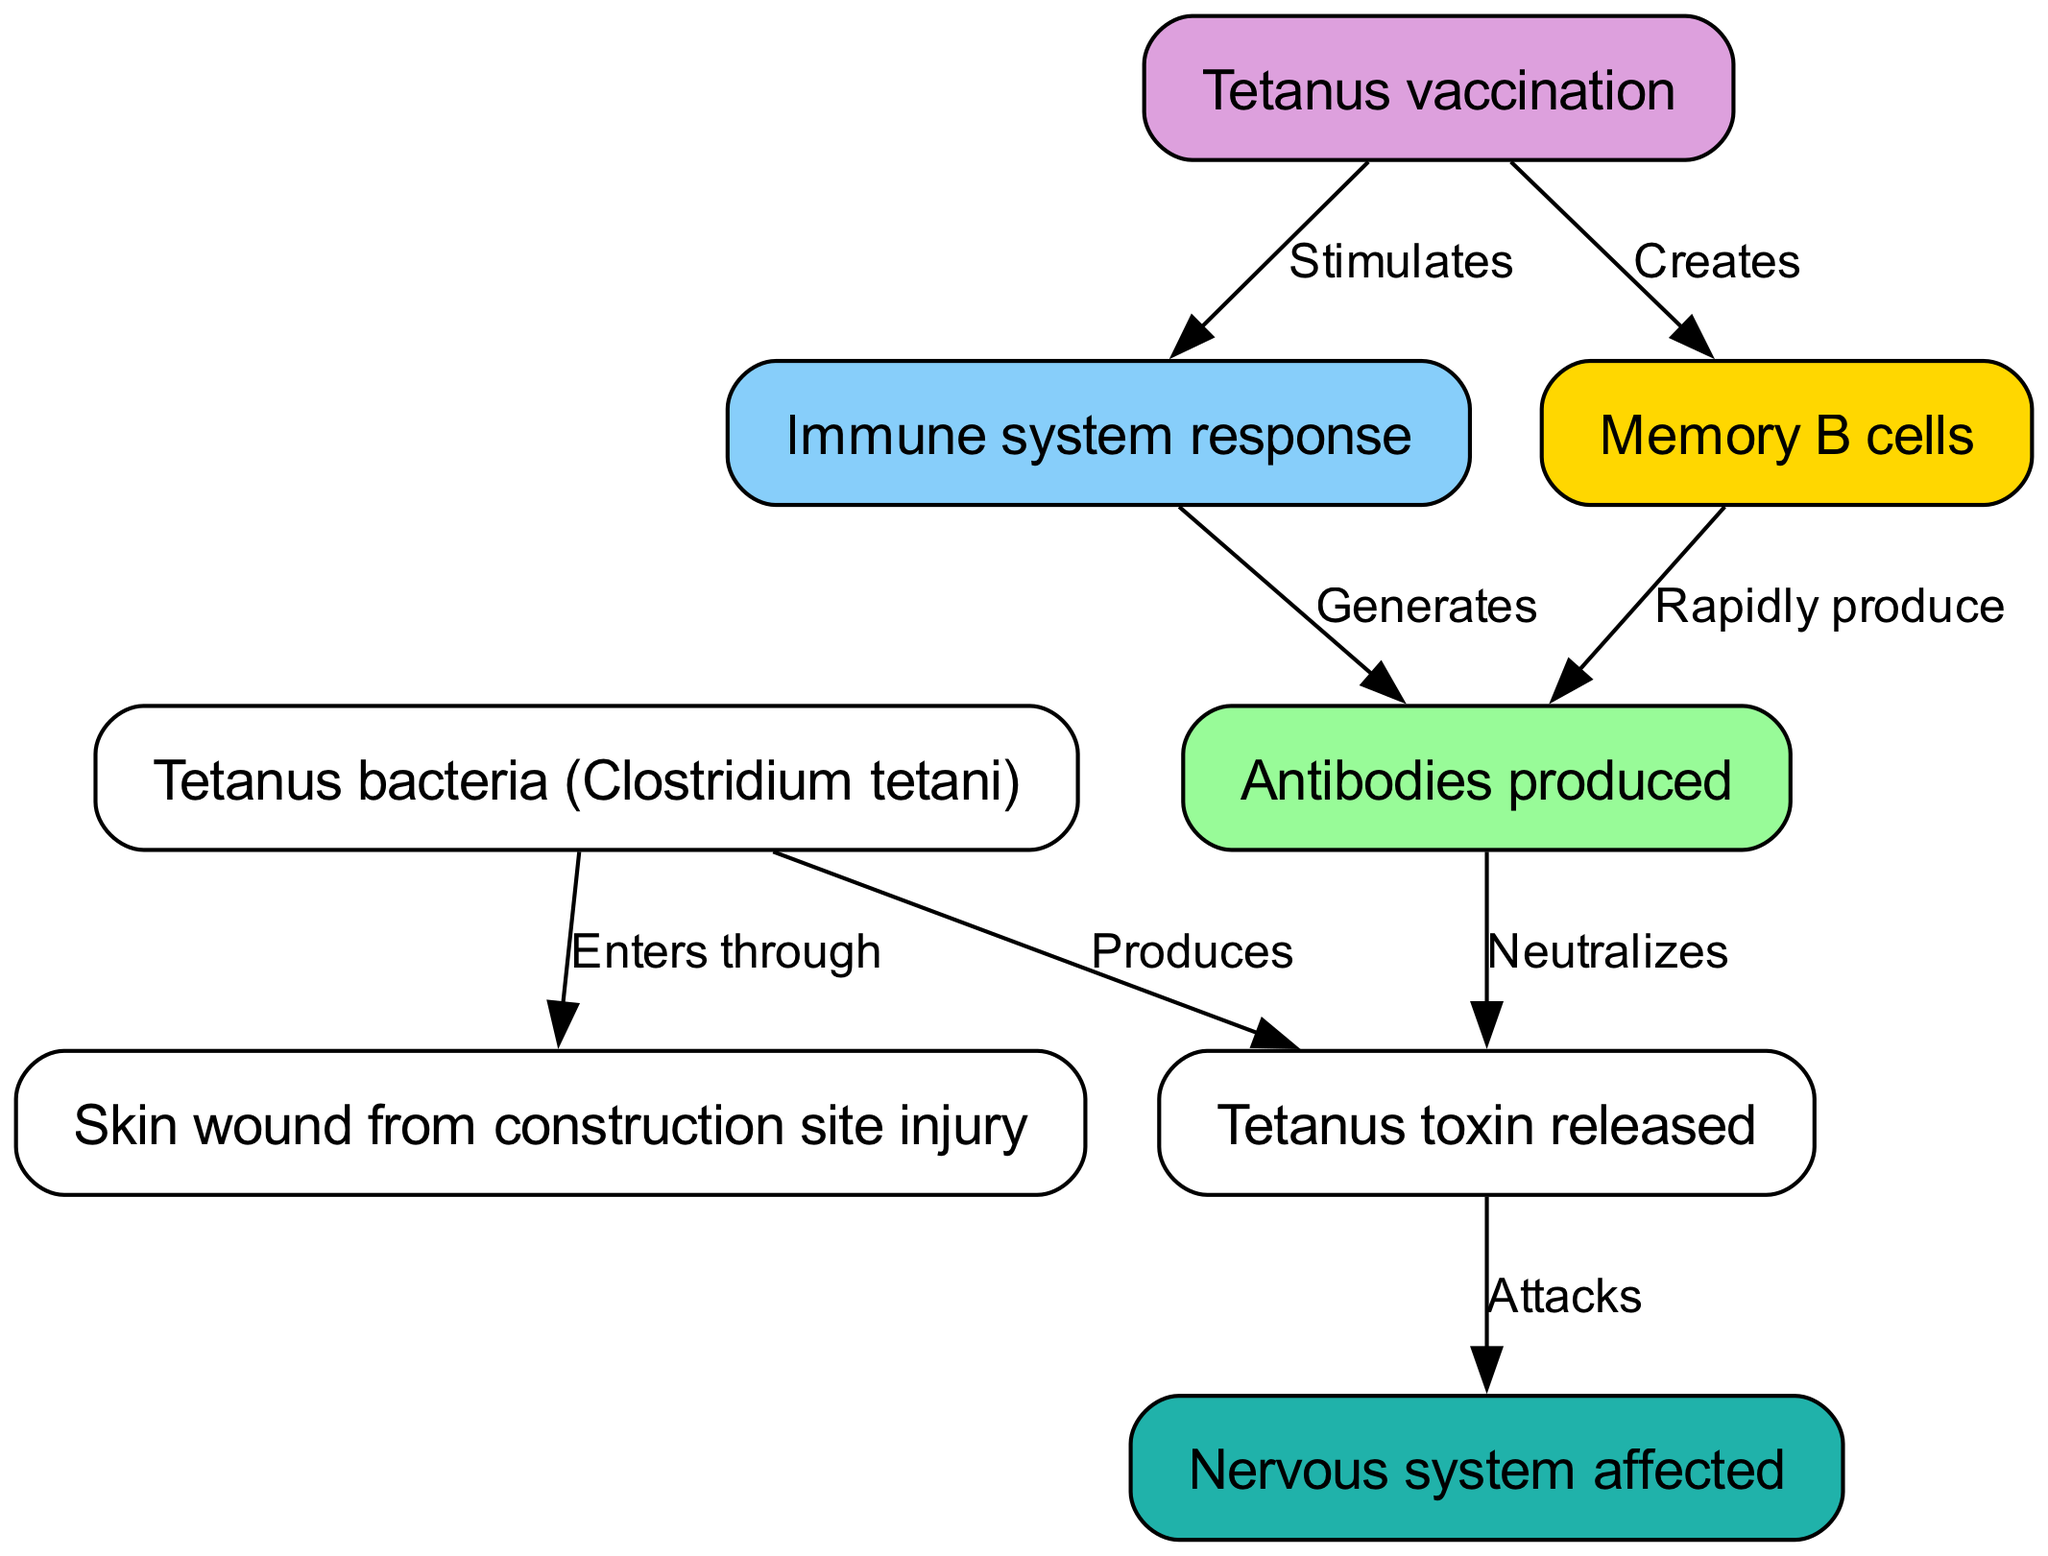What enters through a skin wound? The diagram shows the relationship where the Tetanus bacteria (Clostridium tetani) enters through a skin wound. This is explicitly stated in the edge linking these two nodes with the label "Enters through."
Answer: Tetanus bacteria (Clostridium tetani) How many nodes are present in this diagram? The total number of nodes is derived from counting the "nodes" section in the data, which lists eight nodes, each representing a different part of the immune response to tetanus.
Answer: 8 What does the tetanus toxin attack? According to the diagram, the tetanus toxin directly attacks the nervous system, as indicated by the edge connecting these two nodes, labeled "Attacks."
Answer: Nervous system What does vaccination stimulate? The diagram illustrates that vaccination stimulates the immune response, which is represented by the edge from the vaccination node to the immune response node, labeled "Stimulates."
Answer: Immune response What are produced by memory B cells? The diagram shows a flow from the memory B cells to the antibodies, indicating that memory B cells rapidly produce antibodies, as detailed in the edge from memory cells to antibodies, labeled "Rapidly produce."
Answer: Antibodies What is produced by tetanus bacteria? The diagram specifies that the Tetanus bacteria produces tetanus toxin, illustrated by the edge connecting the two with the label "Produces."
Answer: Tetanus toxin How does the immune system respond? The diagram represents the immune system response as generating antibodies, indicated by the edge that connects the immune response node to the antibodies node with the label "Generates."
Answer: Generates antibodies How does vaccination create memory B cells? The diagram indicates that vaccination directly creates memory B cells, shown as an edge from the vaccination node to the memory cells node with the label "Creates."
Answer: Memory B cells 